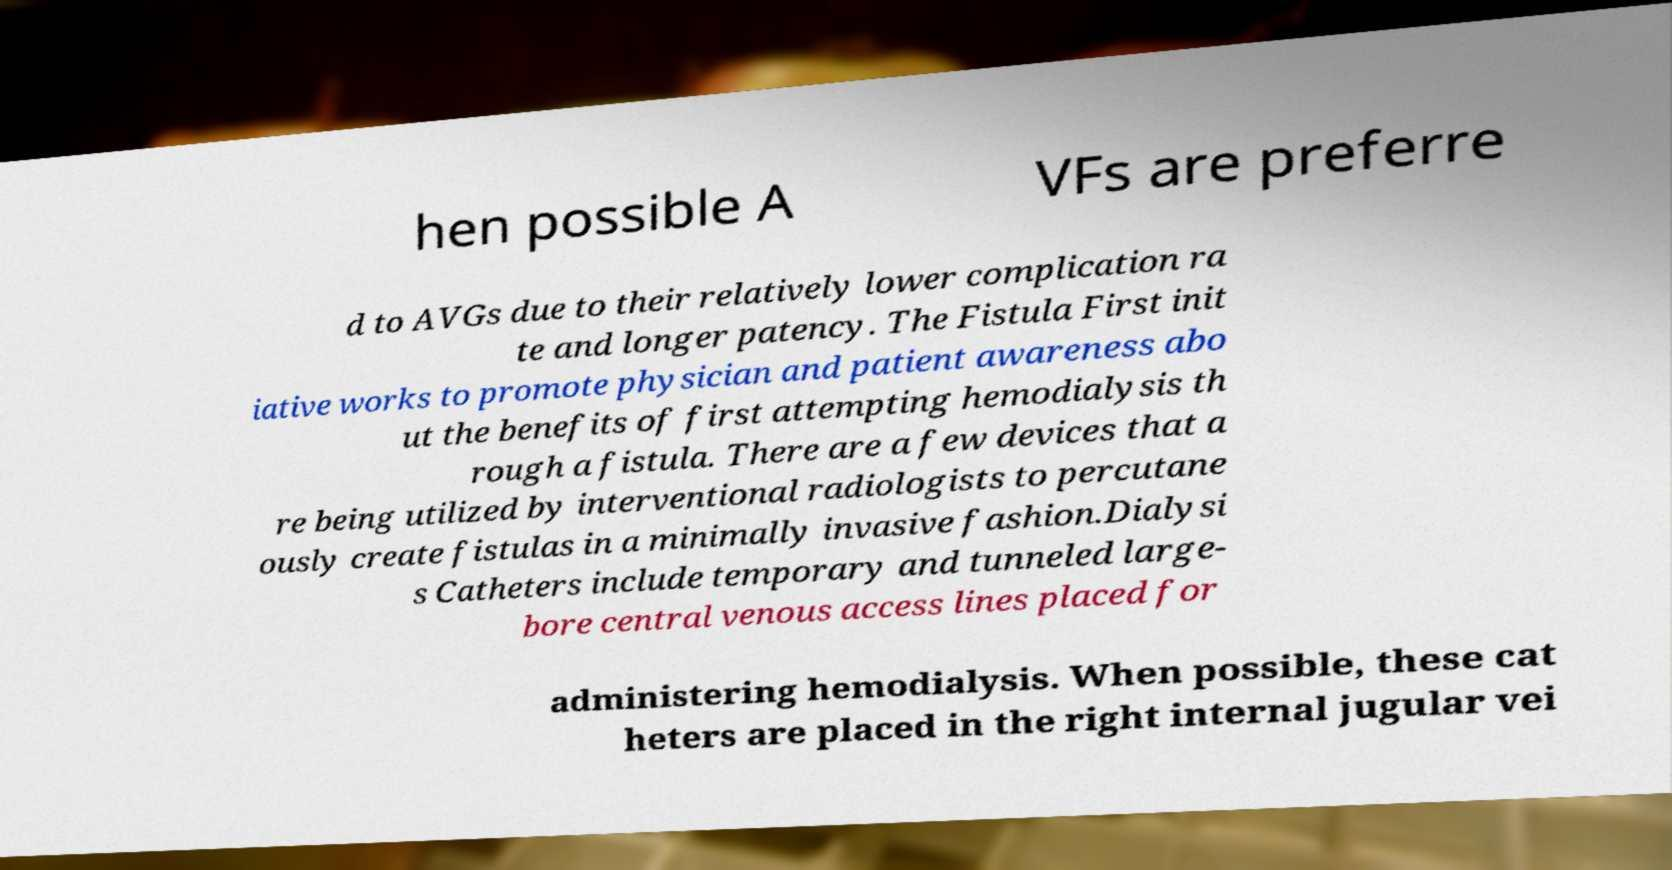Please identify and transcribe the text found in this image. hen possible A VFs are preferre d to AVGs due to their relatively lower complication ra te and longer patency. The Fistula First init iative works to promote physician and patient awareness abo ut the benefits of first attempting hemodialysis th rough a fistula. There are a few devices that a re being utilized by interventional radiologists to percutane ously create fistulas in a minimally invasive fashion.Dialysi s Catheters include temporary and tunneled large- bore central venous access lines placed for administering hemodialysis. When possible, these cat heters are placed in the right internal jugular vei 